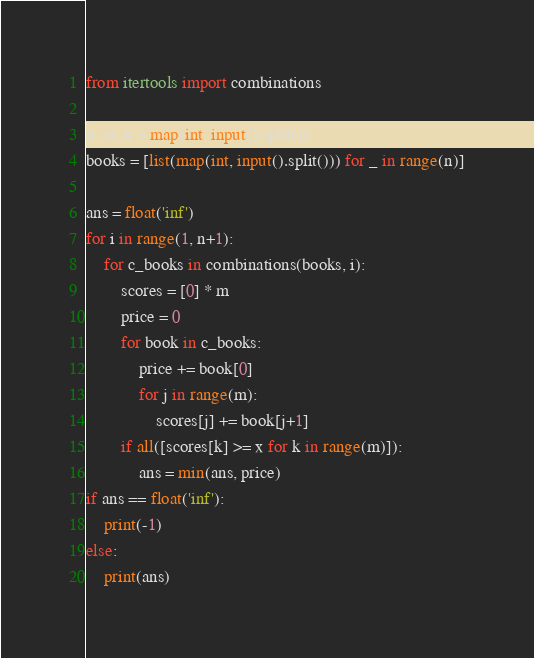Convert code to text. <code><loc_0><loc_0><loc_500><loc_500><_Python_>from itertools import combinations

n, m, x = map(int, input().split())
books = [list(map(int, input().split())) for _ in range(n)]

ans = float('inf')
for i in range(1, n+1):
    for c_books in combinations(books, i):
        scores = [0] * m
        price = 0
        for book in c_books:
            price += book[0]
            for j in range(m):
                scores[j] += book[j+1]
        if all([scores[k] >= x for k in range(m)]):
            ans = min(ans, price)
if ans == float('inf'):
    print(-1)
else:
    print(ans)</code> 